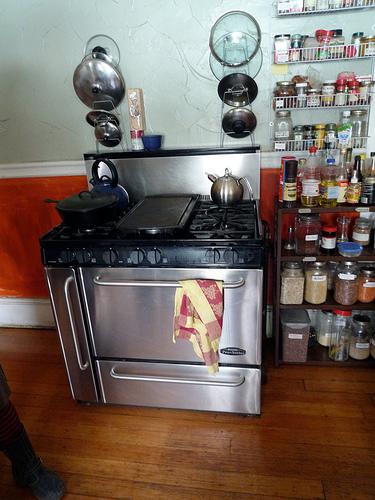Where is the teapot?
Be succinct. Stove. Are the shelves by the oven empty?
Write a very short answer. No. Does is hanging on the front of the stove?
Answer briefly. Towel. 